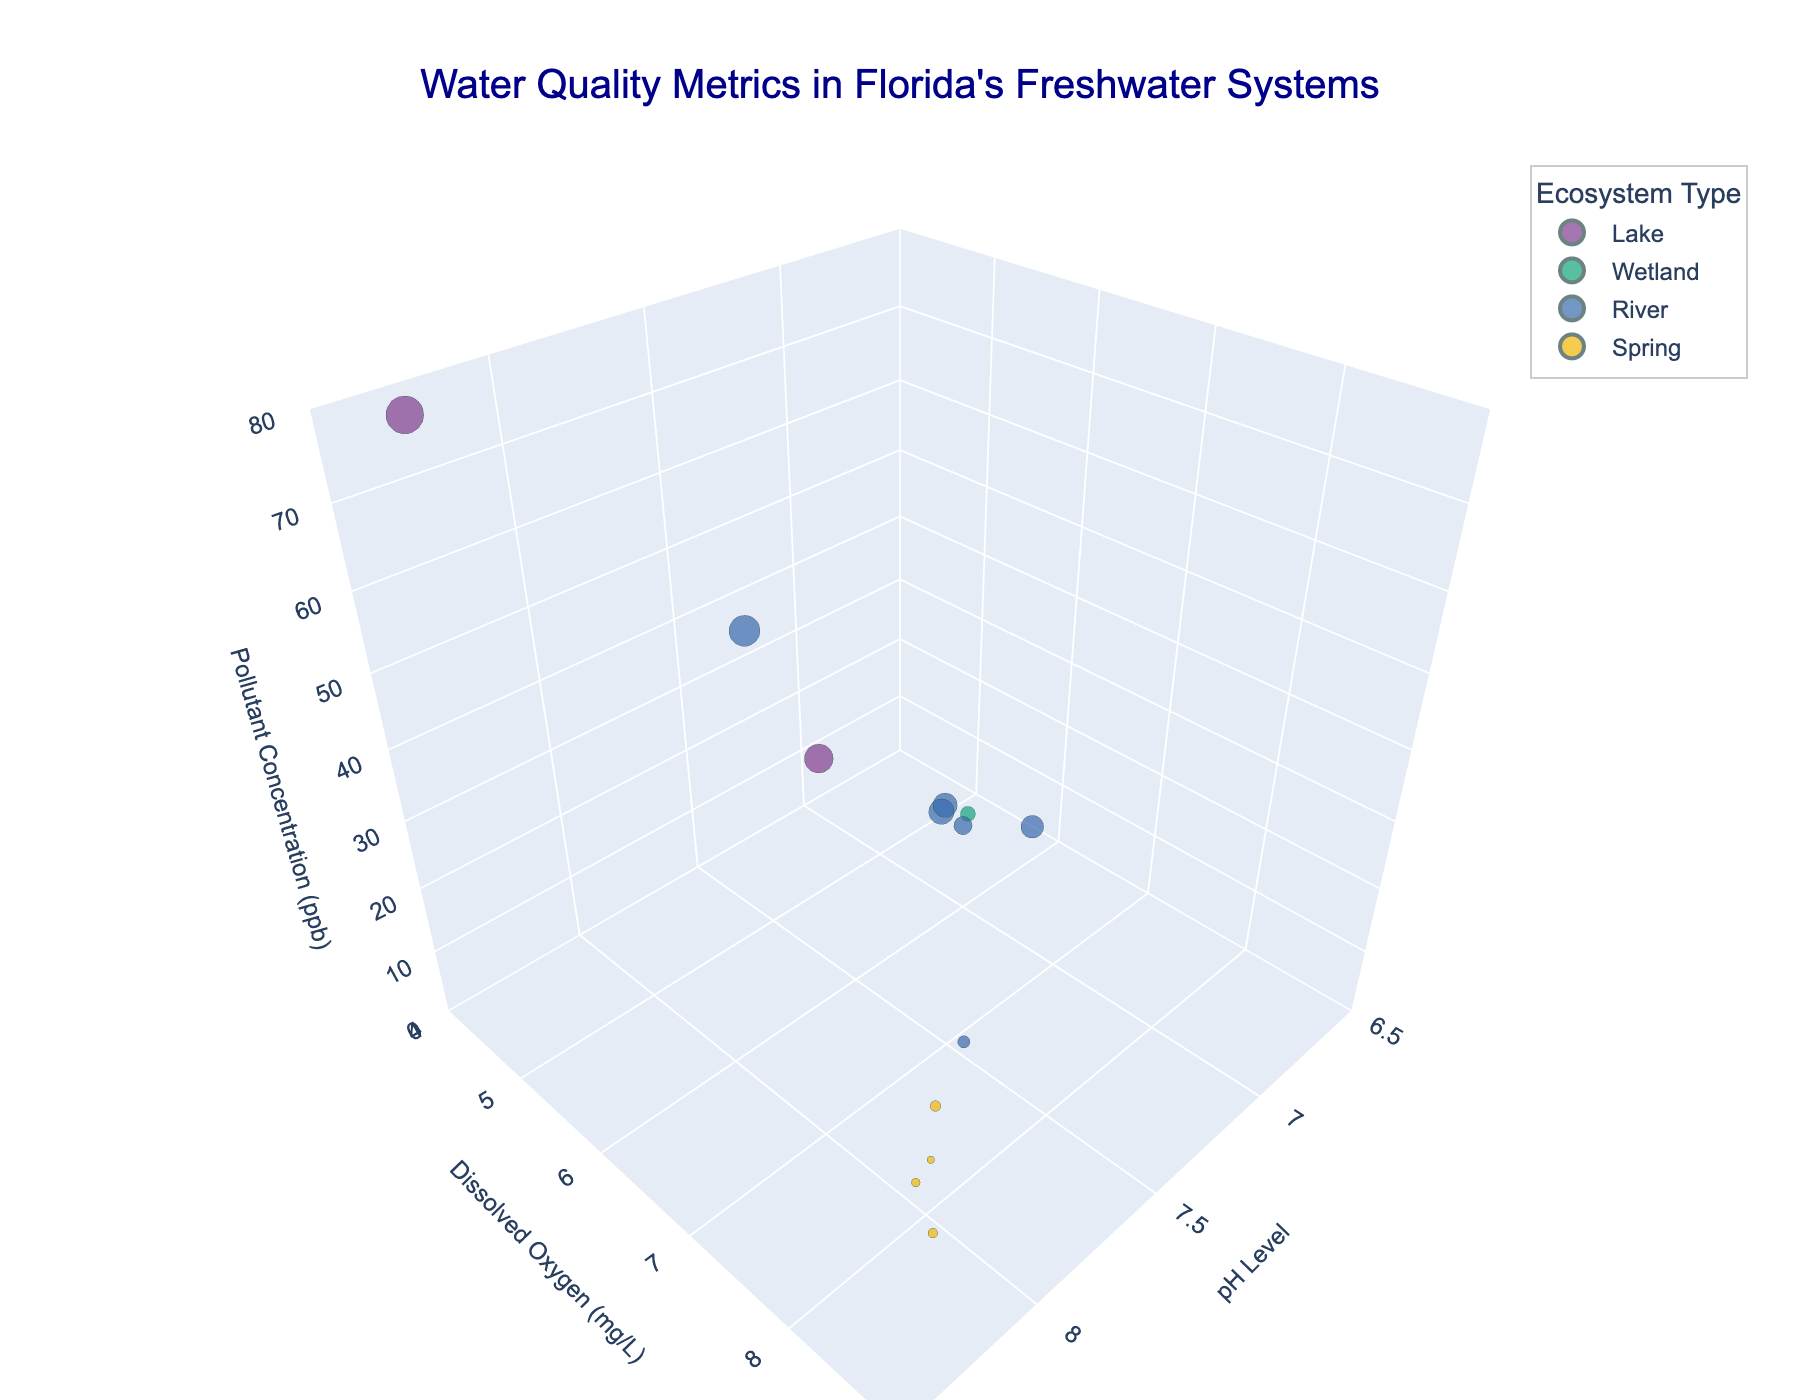What is the title of the figure? The title of the figure is typically displayed at the top.
Answer: Water Quality Metrics in Florida's Freshwater Systems Which location has the highest pollutant concentration? Locate the data point with the highest value on the pollutant concentration axis, which is the z-axis.
Answer: Lake Apopka How many data points represent river ecosystems? Identify the color representing the river ecosystem in the legend and count the corresponding data points.
Answer: 6 Which location has the highest dissolved oxygen level? Check the data point with the highest value on the dissolved oxygen axis, which is the y-axis.
Answer: Silver Springs What is the average pH level across all ecosystems? To calculate the average, sum all pH levels and divide by the number of data points. (7.8+6.9+7.2+8.1+7.5+7.7+7.9+7.6+8.3+7.1+7.8+7.4+8.0) / 13 = 7.6
Answer: 7.6 Compare the dissolved oxygen levels between Lake Okeechobee and Everglades National Park. Refer to the dissolved oxygen values for Lake Okeechobee and Everglades National Park and compare them. Lake Okeechobee has 6.5 mg/L, and Everglades National Park has 5.8 mg/L.
Answer: Lake Okeechobee has higher dissolved oxygen Which ecosystem type generally has the lowest pollutant concentration? Compare the pollutant concentrations in the different ecosystem types and identify the type with the lowest values.
Answer: Spring What is the range of pH levels in this figure? Identify the minimum and maximum pH levels shown in the figure. Minimum is 6.9 and maximum is 8.3.
Answer: 6.9 to 8.3 Which location has the cleanest water in terms of pollutant concentration? Find the location with the smallest value on the pollutant concentration axis (z-axis).
Answer: Wekiwa Springs How many locations have a pH level greater than 8.0? Identify the data points with pH levels greater than 8.0 and count them.
Answer: 4 